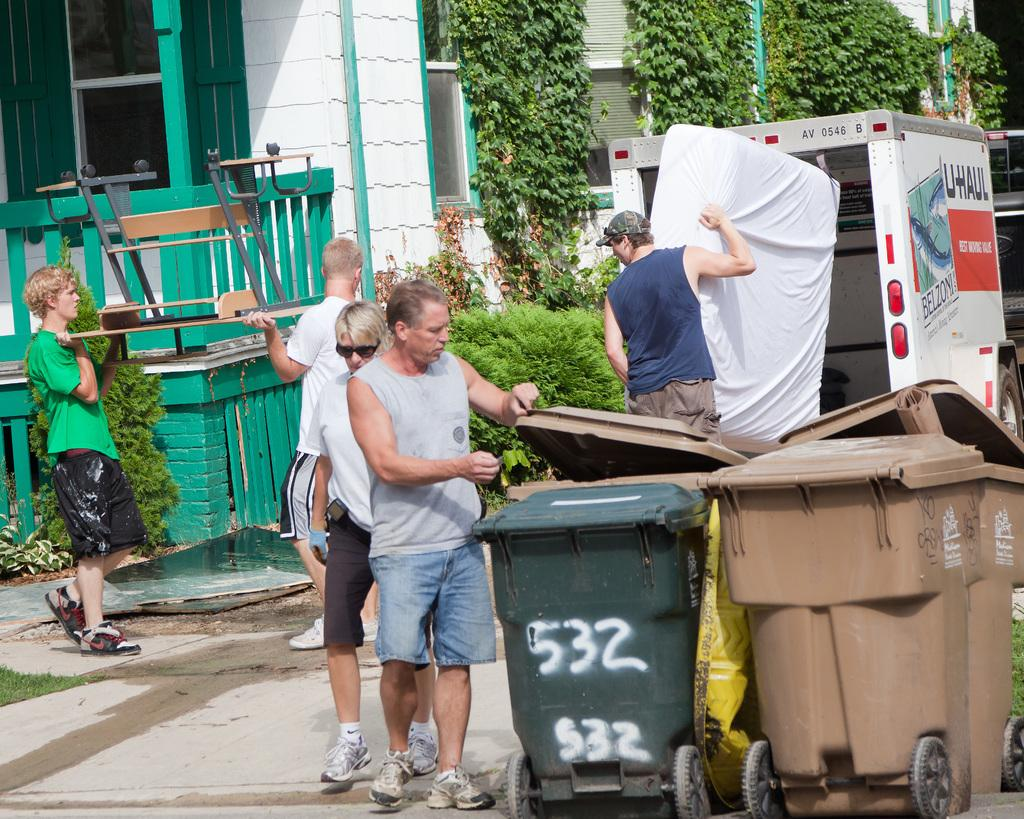<image>
Write a terse but informative summary of the picture. Men load furniture including a mattress into a U-Haul truck. 